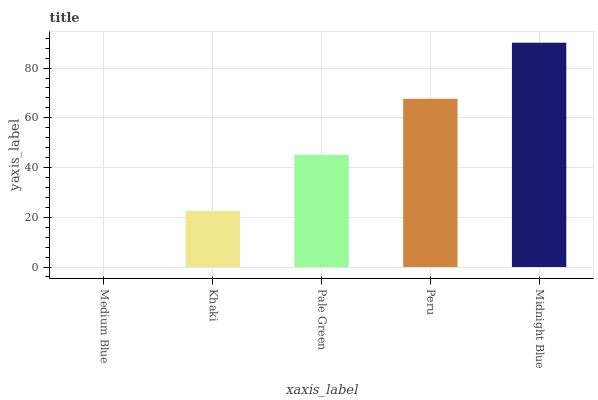Is Medium Blue the minimum?
Answer yes or no. Yes. Is Midnight Blue the maximum?
Answer yes or no. Yes. Is Khaki the minimum?
Answer yes or no. No. Is Khaki the maximum?
Answer yes or no. No. Is Khaki greater than Medium Blue?
Answer yes or no. Yes. Is Medium Blue less than Khaki?
Answer yes or no. Yes. Is Medium Blue greater than Khaki?
Answer yes or no. No. Is Khaki less than Medium Blue?
Answer yes or no. No. Is Pale Green the high median?
Answer yes or no. Yes. Is Pale Green the low median?
Answer yes or no. Yes. Is Medium Blue the high median?
Answer yes or no. No. Is Medium Blue the low median?
Answer yes or no. No. 